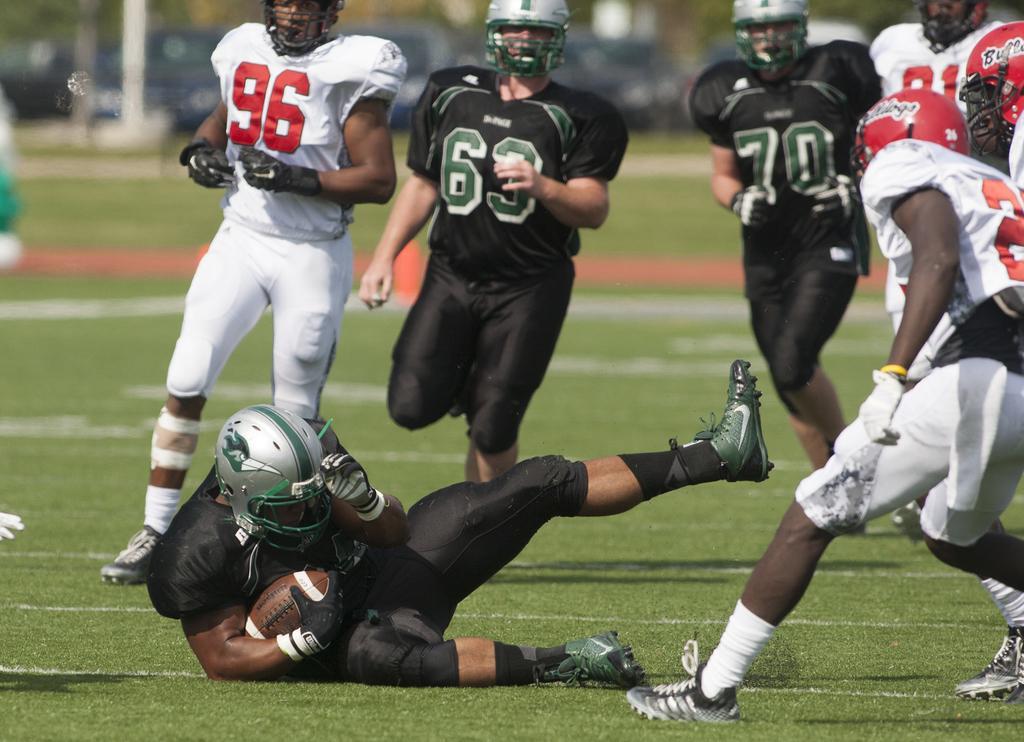Describe this image in one or two sentences. In this image we can see people playing a game. At the bottom there is a man sitting on the ground and holding a ball. 